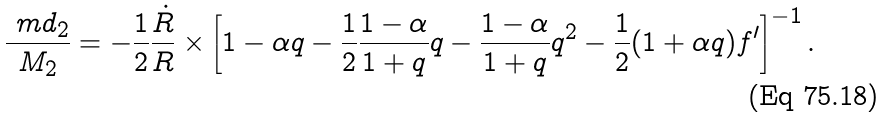<formula> <loc_0><loc_0><loc_500><loc_500>\frac { \ m d _ { 2 } } { M _ { 2 } } = - \frac { 1 } { 2 } \frac { \dot { R } } { R } \times \left [ 1 - \alpha q - \frac { 1 } { 2 } \frac { 1 - \alpha } { 1 + q } q - \frac { 1 - \alpha } { 1 + q } q ^ { 2 } - \frac { 1 } { 2 } ( 1 + \alpha q ) f ^ { \prime } \right ] ^ { - 1 } .</formula> 